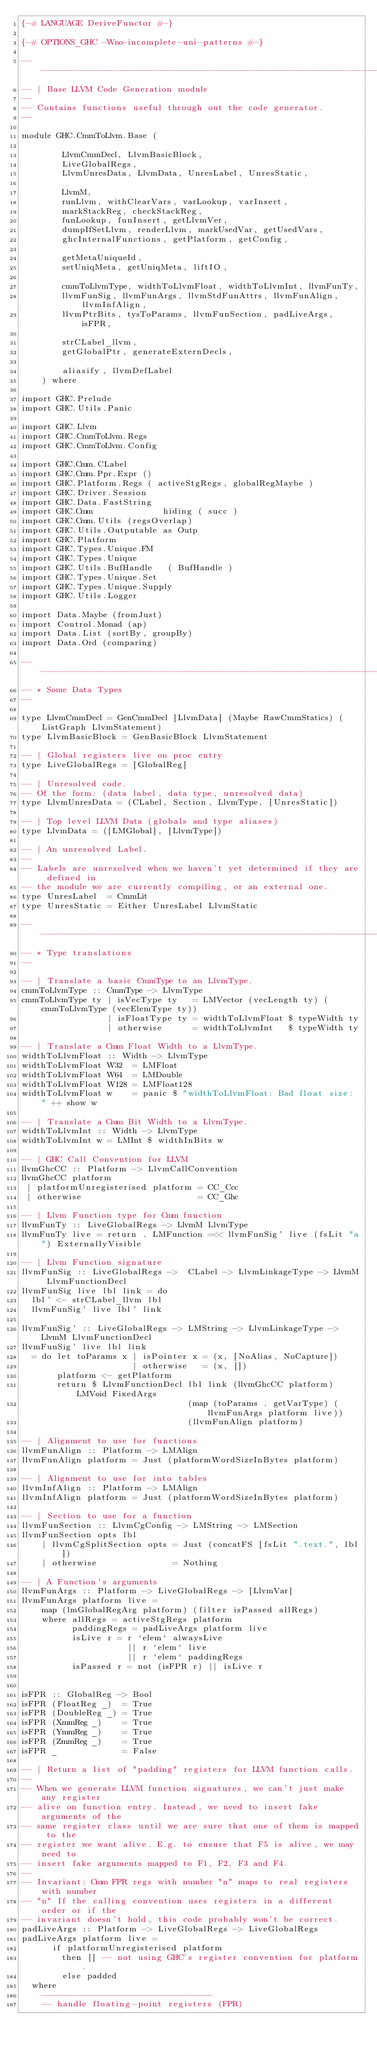Convert code to text. <code><loc_0><loc_0><loc_500><loc_500><_Haskell_>{-# LANGUAGE DeriveFunctor #-}

{-# OPTIONS_GHC -Wno-incomplete-uni-patterns #-}

-- ----------------------------------------------------------------------------
-- | Base LLVM Code Generation module
--
-- Contains functions useful through out the code generator.
--

module GHC.CmmToLlvm.Base (

        LlvmCmmDecl, LlvmBasicBlock,
        LiveGlobalRegs,
        LlvmUnresData, LlvmData, UnresLabel, UnresStatic,

        LlvmM,
        runLlvm, withClearVars, varLookup, varInsert,
        markStackReg, checkStackReg,
        funLookup, funInsert, getLlvmVer,
        dumpIfSetLlvm, renderLlvm, markUsedVar, getUsedVars,
        ghcInternalFunctions, getPlatform, getConfig,

        getMetaUniqueId,
        setUniqMeta, getUniqMeta, liftIO,

        cmmToLlvmType, widthToLlvmFloat, widthToLlvmInt, llvmFunTy,
        llvmFunSig, llvmFunArgs, llvmStdFunAttrs, llvmFunAlign, llvmInfAlign,
        llvmPtrBits, tysToParams, llvmFunSection, padLiveArgs, isFPR,

        strCLabel_llvm,
        getGlobalPtr, generateExternDecls,

        aliasify, llvmDefLabel
    ) where

import GHC.Prelude
import GHC.Utils.Panic

import GHC.Llvm
import GHC.CmmToLlvm.Regs
import GHC.CmmToLlvm.Config

import GHC.Cmm.CLabel
import GHC.Cmm.Ppr.Expr ()
import GHC.Platform.Regs ( activeStgRegs, globalRegMaybe )
import GHC.Driver.Session
import GHC.Data.FastString
import GHC.Cmm              hiding ( succ )
import GHC.Cmm.Utils (regsOverlap)
import GHC.Utils.Outputable as Outp
import GHC.Platform
import GHC.Types.Unique.FM
import GHC.Types.Unique
import GHC.Utils.BufHandle   ( BufHandle )
import GHC.Types.Unique.Set
import GHC.Types.Unique.Supply
import GHC.Utils.Logger

import Data.Maybe (fromJust)
import Control.Monad (ap)
import Data.List (sortBy, groupBy)
import Data.Ord (comparing)

-- ----------------------------------------------------------------------------
-- * Some Data Types
--

type LlvmCmmDecl = GenCmmDecl [LlvmData] (Maybe RawCmmStatics) (ListGraph LlvmStatement)
type LlvmBasicBlock = GenBasicBlock LlvmStatement

-- | Global registers live on proc entry
type LiveGlobalRegs = [GlobalReg]

-- | Unresolved code.
-- Of the form: (data label, data type, unresolved data)
type LlvmUnresData = (CLabel, Section, LlvmType, [UnresStatic])

-- | Top level LLVM Data (globals and type aliases)
type LlvmData = ([LMGlobal], [LlvmType])

-- | An unresolved Label.
--
-- Labels are unresolved when we haven't yet determined if they are defined in
-- the module we are currently compiling, or an external one.
type UnresLabel  = CmmLit
type UnresStatic = Either UnresLabel LlvmStatic

-- ----------------------------------------------------------------------------
-- * Type translations
--

-- | Translate a basic CmmType to an LlvmType.
cmmToLlvmType :: CmmType -> LlvmType
cmmToLlvmType ty | isVecType ty   = LMVector (vecLength ty) (cmmToLlvmType (vecElemType ty))
                 | isFloatType ty = widthToLlvmFloat $ typeWidth ty
                 | otherwise      = widthToLlvmInt   $ typeWidth ty

-- | Translate a Cmm Float Width to a LlvmType.
widthToLlvmFloat :: Width -> LlvmType
widthToLlvmFloat W32  = LMFloat
widthToLlvmFloat W64  = LMDouble
widthToLlvmFloat W128 = LMFloat128
widthToLlvmFloat w    = panic $ "widthToLlvmFloat: Bad float size: " ++ show w

-- | Translate a Cmm Bit Width to a LlvmType.
widthToLlvmInt :: Width -> LlvmType
widthToLlvmInt w = LMInt $ widthInBits w

-- | GHC Call Convention for LLVM
llvmGhcCC :: Platform -> LlvmCallConvention
llvmGhcCC platform
 | platformUnregisterised platform = CC_Ccc
 | otherwise                       = CC_Ghc

-- | Llvm Function type for Cmm function
llvmFunTy :: LiveGlobalRegs -> LlvmM LlvmType
llvmFunTy live = return . LMFunction =<< llvmFunSig' live (fsLit "a") ExternallyVisible

-- | Llvm Function signature
llvmFunSig :: LiveGlobalRegs ->  CLabel -> LlvmLinkageType -> LlvmM LlvmFunctionDecl
llvmFunSig live lbl link = do
  lbl' <- strCLabel_llvm lbl
  llvmFunSig' live lbl' link

llvmFunSig' :: LiveGlobalRegs -> LMString -> LlvmLinkageType -> LlvmM LlvmFunctionDecl
llvmFunSig' live lbl link
  = do let toParams x | isPointer x = (x, [NoAlias, NoCapture])
                      | otherwise   = (x, [])
       platform <- getPlatform
       return $ LlvmFunctionDecl lbl link (llvmGhcCC platform) LMVoid FixedArgs
                                 (map (toParams . getVarType) (llvmFunArgs platform live))
                                 (llvmFunAlign platform)

-- | Alignment to use for functions
llvmFunAlign :: Platform -> LMAlign
llvmFunAlign platform = Just (platformWordSizeInBytes platform)

-- | Alignment to use for into tables
llvmInfAlign :: Platform -> LMAlign
llvmInfAlign platform = Just (platformWordSizeInBytes platform)

-- | Section to use for a function
llvmFunSection :: LlvmCgConfig -> LMString -> LMSection
llvmFunSection opts lbl
    | llvmCgSplitSection opts = Just (concatFS [fsLit ".text.", lbl])
    | otherwise               = Nothing

-- | A Function's arguments
llvmFunArgs :: Platform -> LiveGlobalRegs -> [LlvmVar]
llvmFunArgs platform live =
    map (lmGlobalRegArg platform) (filter isPassed allRegs)
    where allRegs = activeStgRegs platform
          paddingRegs = padLiveArgs platform live
          isLive r = r `elem` alwaysLive
                     || r `elem` live
                     || r `elem` paddingRegs
          isPassed r = not (isFPR r) || isLive r


isFPR :: GlobalReg -> Bool
isFPR (FloatReg _)  = True
isFPR (DoubleReg _) = True
isFPR (XmmReg _)    = True
isFPR (YmmReg _)    = True
isFPR (ZmmReg _)    = True
isFPR _             = False

-- | Return a list of "padding" registers for LLVM function calls.
--
-- When we generate LLVM function signatures, we can't just make any register
-- alive on function entry. Instead, we need to insert fake arguments of the
-- same register class until we are sure that one of them is mapped to the
-- register we want alive. E.g. to ensure that F5 is alive, we may need to
-- insert fake arguments mapped to F1, F2, F3 and F4.
--
-- Invariant: Cmm FPR regs with number "n" maps to real registers with number
-- "n" If the calling convention uses registers in a different order or if the
-- invariant doesn't hold, this code probably won't be correct.
padLiveArgs :: Platform -> LiveGlobalRegs -> LiveGlobalRegs
padLiveArgs platform live =
      if platformUnregisterised platform
        then [] -- not using GHC's register convention for platform.
        else padded
  where
    ----------------------------------
    -- handle floating-point registers (FPR)
</code> 